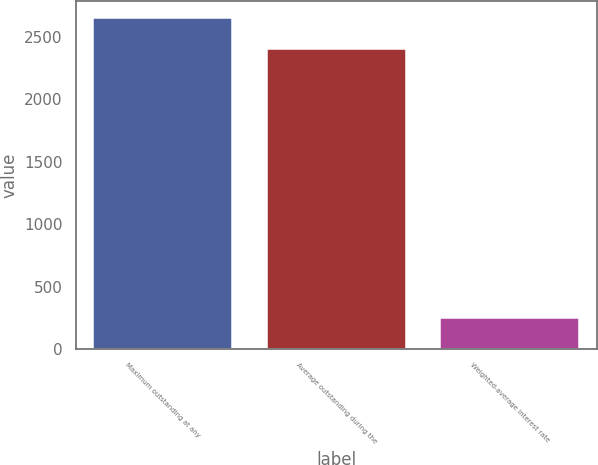Convert chart. <chart><loc_0><loc_0><loc_500><loc_500><bar_chart><fcel>Maximum outstanding at any<fcel>Average outstanding during the<fcel>Weighted-average interest rate<nl><fcel>2651.28<fcel>2404<fcel>247.46<nl></chart> 